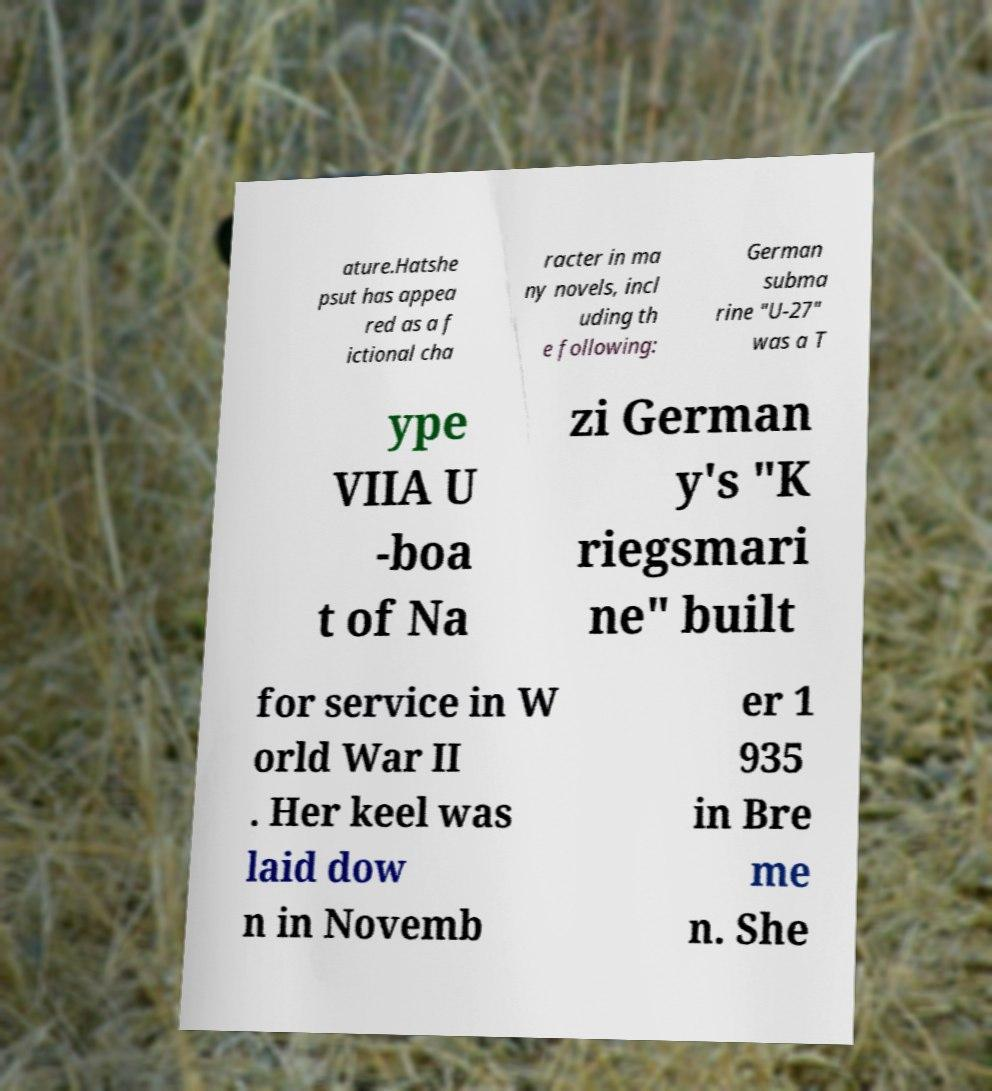What messages or text are displayed in this image? I need them in a readable, typed format. ature.Hatshe psut has appea red as a f ictional cha racter in ma ny novels, incl uding th e following: German subma rine "U-27" was a T ype VIIA U -boa t of Na zi German y's "K riegsmari ne" built for service in W orld War II . Her keel was laid dow n in Novemb er 1 935 in Bre me n. She 